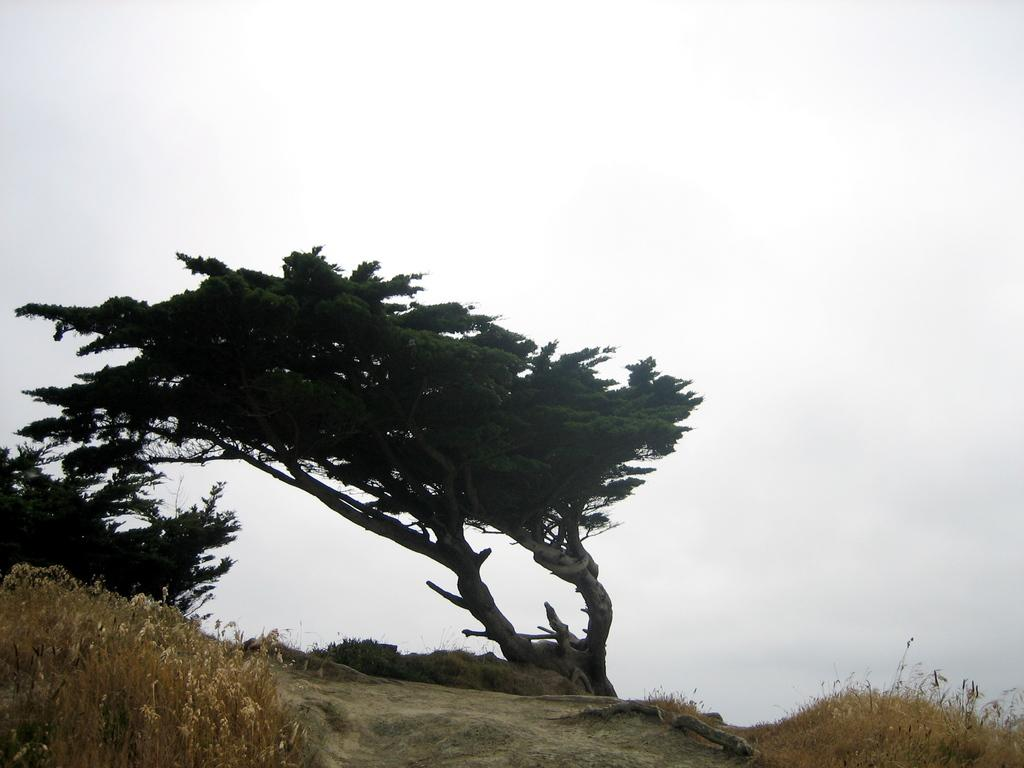What is visible on the ground in the image? The ground is visible in the image. What type of vegetation can be seen in the image? There are plants and trees in the image. What is visible in the background of the image? The sky is visible in the background of the image. Can you see a rifle in the image? No, there is no rifle present in the image. How many fingers are visible in the image? There are no fingers visible in the image. 